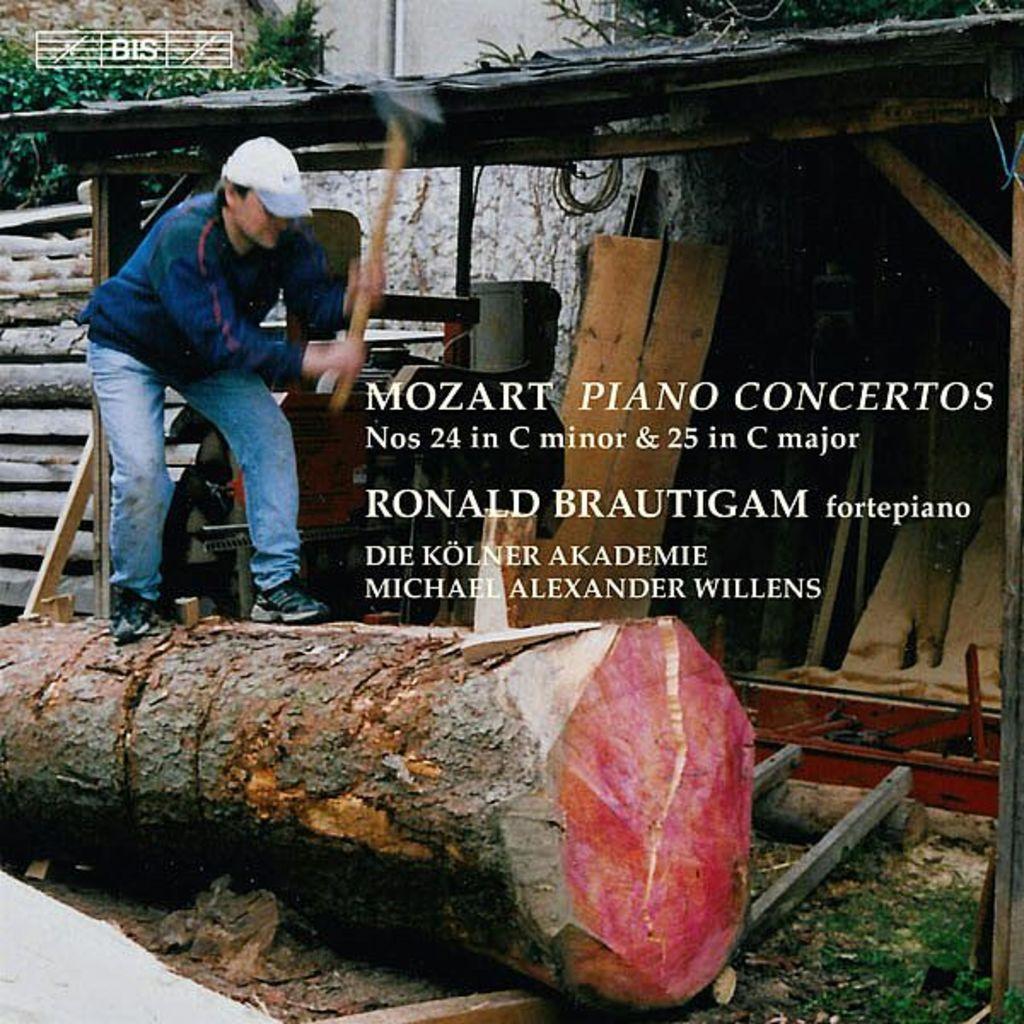How would you summarize this image in a sentence or two? In this image, there is a person standing on the wood beside the shed. This person is holding an ax with his hands. There is a text in the middle of the image. 